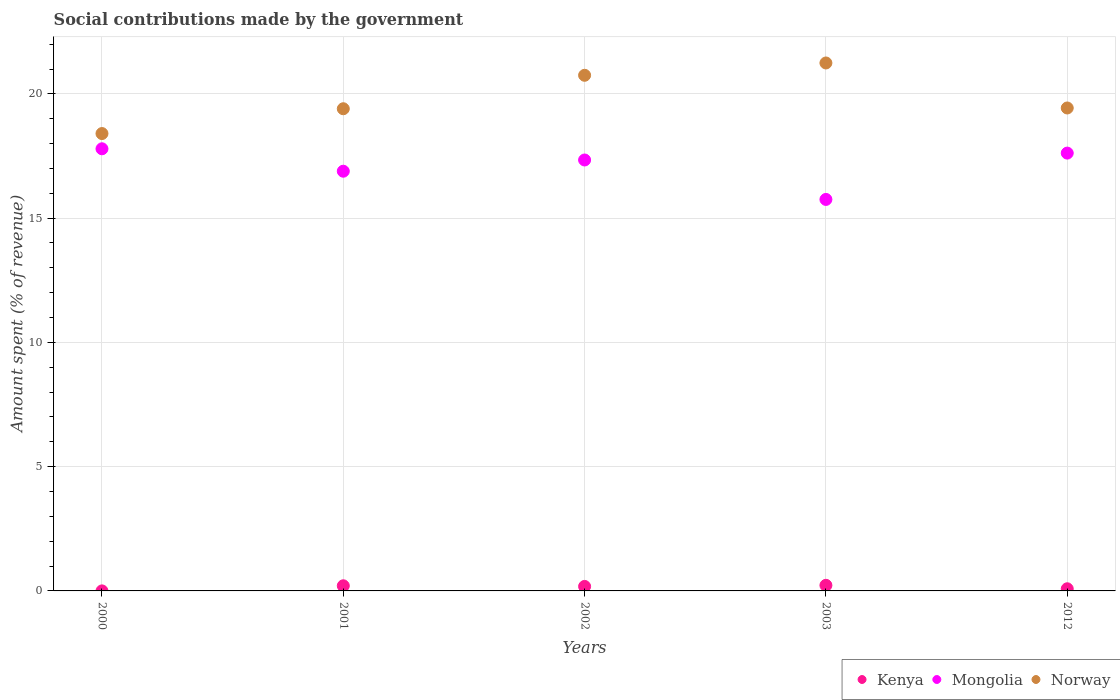How many different coloured dotlines are there?
Your answer should be compact. 3. What is the amount spent (in %) on social contributions in Mongolia in 2001?
Offer a terse response. 16.89. Across all years, what is the maximum amount spent (in %) on social contributions in Mongolia?
Keep it short and to the point. 17.79. Across all years, what is the minimum amount spent (in %) on social contributions in Kenya?
Ensure brevity in your answer.  0. In which year was the amount spent (in %) on social contributions in Norway minimum?
Give a very brief answer. 2000. What is the total amount spent (in %) on social contributions in Mongolia in the graph?
Keep it short and to the point. 85.39. What is the difference between the amount spent (in %) on social contributions in Kenya in 2001 and that in 2002?
Your answer should be very brief. 0.03. What is the difference between the amount spent (in %) on social contributions in Norway in 2003 and the amount spent (in %) on social contributions in Mongolia in 2001?
Provide a short and direct response. 4.36. What is the average amount spent (in %) on social contributions in Mongolia per year?
Your response must be concise. 17.08. In the year 2002, what is the difference between the amount spent (in %) on social contributions in Mongolia and amount spent (in %) on social contributions in Kenya?
Offer a terse response. 17.16. In how many years, is the amount spent (in %) on social contributions in Norway greater than 19 %?
Ensure brevity in your answer.  4. What is the ratio of the amount spent (in %) on social contributions in Kenya in 2002 to that in 2003?
Provide a succinct answer. 0.8. Is the amount spent (in %) on social contributions in Mongolia in 2000 less than that in 2001?
Your answer should be very brief. No. Is the difference between the amount spent (in %) on social contributions in Mongolia in 2002 and 2003 greater than the difference between the amount spent (in %) on social contributions in Kenya in 2002 and 2003?
Offer a very short reply. Yes. What is the difference between the highest and the second highest amount spent (in %) on social contributions in Mongolia?
Make the answer very short. 0.17. What is the difference between the highest and the lowest amount spent (in %) on social contributions in Norway?
Provide a short and direct response. 2.84. Is the sum of the amount spent (in %) on social contributions in Mongolia in 2001 and 2002 greater than the maximum amount spent (in %) on social contributions in Kenya across all years?
Your answer should be compact. Yes. Is it the case that in every year, the sum of the amount spent (in %) on social contributions in Norway and amount spent (in %) on social contributions in Kenya  is greater than the amount spent (in %) on social contributions in Mongolia?
Keep it short and to the point. Yes. Is the amount spent (in %) on social contributions in Kenya strictly greater than the amount spent (in %) on social contributions in Norway over the years?
Give a very brief answer. No. Is the amount spent (in %) on social contributions in Kenya strictly less than the amount spent (in %) on social contributions in Mongolia over the years?
Ensure brevity in your answer.  Yes. How many dotlines are there?
Your response must be concise. 3. How many years are there in the graph?
Keep it short and to the point. 5. What is the difference between two consecutive major ticks on the Y-axis?
Provide a succinct answer. 5. Are the values on the major ticks of Y-axis written in scientific E-notation?
Keep it short and to the point. No. Does the graph contain grids?
Give a very brief answer. Yes. Where does the legend appear in the graph?
Your answer should be very brief. Bottom right. How many legend labels are there?
Ensure brevity in your answer.  3. How are the legend labels stacked?
Your answer should be very brief. Horizontal. What is the title of the graph?
Give a very brief answer. Social contributions made by the government. What is the label or title of the Y-axis?
Offer a very short reply. Amount spent (% of revenue). What is the Amount spent (% of revenue) of Kenya in 2000?
Provide a short and direct response. 0. What is the Amount spent (% of revenue) in Mongolia in 2000?
Offer a very short reply. 17.79. What is the Amount spent (% of revenue) in Norway in 2000?
Give a very brief answer. 18.4. What is the Amount spent (% of revenue) in Kenya in 2001?
Give a very brief answer. 0.21. What is the Amount spent (% of revenue) in Mongolia in 2001?
Provide a short and direct response. 16.89. What is the Amount spent (% of revenue) in Norway in 2001?
Provide a short and direct response. 19.4. What is the Amount spent (% of revenue) in Kenya in 2002?
Provide a succinct answer. 0.18. What is the Amount spent (% of revenue) in Mongolia in 2002?
Your response must be concise. 17.34. What is the Amount spent (% of revenue) of Norway in 2002?
Offer a very short reply. 20.75. What is the Amount spent (% of revenue) of Kenya in 2003?
Your answer should be compact. 0.23. What is the Amount spent (% of revenue) in Mongolia in 2003?
Your response must be concise. 15.75. What is the Amount spent (% of revenue) in Norway in 2003?
Keep it short and to the point. 21.24. What is the Amount spent (% of revenue) of Kenya in 2012?
Your answer should be compact. 0.09. What is the Amount spent (% of revenue) of Mongolia in 2012?
Your answer should be compact. 17.62. What is the Amount spent (% of revenue) of Norway in 2012?
Ensure brevity in your answer.  19.43. Across all years, what is the maximum Amount spent (% of revenue) in Kenya?
Provide a short and direct response. 0.23. Across all years, what is the maximum Amount spent (% of revenue) of Mongolia?
Your answer should be compact. 17.79. Across all years, what is the maximum Amount spent (% of revenue) of Norway?
Your response must be concise. 21.24. Across all years, what is the minimum Amount spent (% of revenue) of Kenya?
Ensure brevity in your answer.  0. Across all years, what is the minimum Amount spent (% of revenue) of Mongolia?
Your answer should be very brief. 15.75. Across all years, what is the minimum Amount spent (% of revenue) in Norway?
Keep it short and to the point. 18.4. What is the total Amount spent (% of revenue) of Mongolia in the graph?
Your answer should be compact. 85.39. What is the total Amount spent (% of revenue) of Norway in the graph?
Offer a terse response. 99.23. What is the difference between the Amount spent (% of revenue) in Kenya in 2000 and that in 2001?
Your answer should be compact. -0.21. What is the difference between the Amount spent (% of revenue) of Mongolia in 2000 and that in 2001?
Offer a very short reply. 0.9. What is the difference between the Amount spent (% of revenue) of Norway in 2000 and that in 2001?
Your answer should be very brief. -1. What is the difference between the Amount spent (% of revenue) in Kenya in 2000 and that in 2002?
Make the answer very short. -0.18. What is the difference between the Amount spent (% of revenue) of Mongolia in 2000 and that in 2002?
Give a very brief answer. 0.45. What is the difference between the Amount spent (% of revenue) in Norway in 2000 and that in 2002?
Make the answer very short. -2.34. What is the difference between the Amount spent (% of revenue) in Kenya in 2000 and that in 2003?
Keep it short and to the point. -0.22. What is the difference between the Amount spent (% of revenue) in Mongolia in 2000 and that in 2003?
Give a very brief answer. 2.04. What is the difference between the Amount spent (% of revenue) of Norway in 2000 and that in 2003?
Your answer should be very brief. -2.84. What is the difference between the Amount spent (% of revenue) of Kenya in 2000 and that in 2012?
Your answer should be compact. -0.09. What is the difference between the Amount spent (% of revenue) in Mongolia in 2000 and that in 2012?
Give a very brief answer. 0.17. What is the difference between the Amount spent (% of revenue) in Norway in 2000 and that in 2012?
Your answer should be compact. -1.03. What is the difference between the Amount spent (% of revenue) of Kenya in 2001 and that in 2002?
Offer a very short reply. 0.03. What is the difference between the Amount spent (% of revenue) in Mongolia in 2001 and that in 2002?
Offer a terse response. -0.45. What is the difference between the Amount spent (% of revenue) of Norway in 2001 and that in 2002?
Offer a terse response. -1.35. What is the difference between the Amount spent (% of revenue) of Kenya in 2001 and that in 2003?
Provide a short and direct response. -0.02. What is the difference between the Amount spent (% of revenue) in Mongolia in 2001 and that in 2003?
Make the answer very short. 1.14. What is the difference between the Amount spent (% of revenue) of Norway in 2001 and that in 2003?
Keep it short and to the point. -1.84. What is the difference between the Amount spent (% of revenue) of Kenya in 2001 and that in 2012?
Ensure brevity in your answer.  0.12. What is the difference between the Amount spent (% of revenue) of Mongolia in 2001 and that in 2012?
Your answer should be compact. -0.73. What is the difference between the Amount spent (% of revenue) in Norway in 2001 and that in 2012?
Provide a short and direct response. -0.03. What is the difference between the Amount spent (% of revenue) in Kenya in 2002 and that in 2003?
Offer a very short reply. -0.04. What is the difference between the Amount spent (% of revenue) in Mongolia in 2002 and that in 2003?
Ensure brevity in your answer.  1.59. What is the difference between the Amount spent (% of revenue) of Norway in 2002 and that in 2003?
Offer a very short reply. -0.5. What is the difference between the Amount spent (% of revenue) in Kenya in 2002 and that in 2012?
Your answer should be compact. 0.09. What is the difference between the Amount spent (% of revenue) in Mongolia in 2002 and that in 2012?
Keep it short and to the point. -0.28. What is the difference between the Amount spent (% of revenue) in Norway in 2002 and that in 2012?
Your answer should be very brief. 1.32. What is the difference between the Amount spent (% of revenue) of Kenya in 2003 and that in 2012?
Offer a terse response. 0.14. What is the difference between the Amount spent (% of revenue) in Mongolia in 2003 and that in 2012?
Make the answer very short. -1.86. What is the difference between the Amount spent (% of revenue) of Norway in 2003 and that in 2012?
Provide a succinct answer. 1.81. What is the difference between the Amount spent (% of revenue) of Kenya in 2000 and the Amount spent (% of revenue) of Mongolia in 2001?
Offer a terse response. -16.89. What is the difference between the Amount spent (% of revenue) in Kenya in 2000 and the Amount spent (% of revenue) in Norway in 2001?
Ensure brevity in your answer.  -19.4. What is the difference between the Amount spent (% of revenue) of Mongolia in 2000 and the Amount spent (% of revenue) of Norway in 2001?
Give a very brief answer. -1.61. What is the difference between the Amount spent (% of revenue) in Kenya in 2000 and the Amount spent (% of revenue) in Mongolia in 2002?
Your answer should be very brief. -17.34. What is the difference between the Amount spent (% of revenue) in Kenya in 2000 and the Amount spent (% of revenue) in Norway in 2002?
Your response must be concise. -20.75. What is the difference between the Amount spent (% of revenue) of Mongolia in 2000 and the Amount spent (% of revenue) of Norway in 2002?
Offer a very short reply. -2.96. What is the difference between the Amount spent (% of revenue) of Kenya in 2000 and the Amount spent (% of revenue) of Mongolia in 2003?
Your answer should be very brief. -15.75. What is the difference between the Amount spent (% of revenue) in Kenya in 2000 and the Amount spent (% of revenue) in Norway in 2003?
Your response must be concise. -21.24. What is the difference between the Amount spent (% of revenue) of Mongolia in 2000 and the Amount spent (% of revenue) of Norway in 2003?
Your answer should be very brief. -3.45. What is the difference between the Amount spent (% of revenue) of Kenya in 2000 and the Amount spent (% of revenue) of Mongolia in 2012?
Give a very brief answer. -17.62. What is the difference between the Amount spent (% of revenue) of Kenya in 2000 and the Amount spent (% of revenue) of Norway in 2012?
Your answer should be compact. -19.43. What is the difference between the Amount spent (% of revenue) in Mongolia in 2000 and the Amount spent (% of revenue) in Norway in 2012?
Keep it short and to the point. -1.64. What is the difference between the Amount spent (% of revenue) in Kenya in 2001 and the Amount spent (% of revenue) in Mongolia in 2002?
Provide a short and direct response. -17.13. What is the difference between the Amount spent (% of revenue) of Kenya in 2001 and the Amount spent (% of revenue) of Norway in 2002?
Your answer should be compact. -20.54. What is the difference between the Amount spent (% of revenue) in Mongolia in 2001 and the Amount spent (% of revenue) in Norway in 2002?
Keep it short and to the point. -3.86. What is the difference between the Amount spent (% of revenue) of Kenya in 2001 and the Amount spent (% of revenue) of Mongolia in 2003?
Keep it short and to the point. -15.55. What is the difference between the Amount spent (% of revenue) in Kenya in 2001 and the Amount spent (% of revenue) in Norway in 2003?
Ensure brevity in your answer.  -21.04. What is the difference between the Amount spent (% of revenue) of Mongolia in 2001 and the Amount spent (% of revenue) of Norway in 2003?
Your response must be concise. -4.36. What is the difference between the Amount spent (% of revenue) of Kenya in 2001 and the Amount spent (% of revenue) of Mongolia in 2012?
Provide a succinct answer. -17.41. What is the difference between the Amount spent (% of revenue) in Kenya in 2001 and the Amount spent (% of revenue) in Norway in 2012?
Offer a terse response. -19.23. What is the difference between the Amount spent (% of revenue) of Mongolia in 2001 and the Amount spent (% of revenue) of Norway in 2012?
Offer a terse response. -2.54. What is the difference between the Amount spent (% of revenue) in Kenya in 2002 and the Amount spent (% of revenue) in Mongolia in 2003?
Give a very brief answer. -15.57. What is the difference between the Amount spent (% of revenue) of Kenya in 2002 and the Amount spent (% of revenue) of Norway in 2003?
Keep it short and to the point. -21.06. What is the difference between the Amount spent (% of revenue) in Mongolia in 2002 and the Amount spent (% of revenue) in Norway in 2003?
Provide a succinct answer. -3.9. What is the difference between the Amount spent (% of revenue) of Kenya in 2002 and the Amount spent (% of revenue) of Mongolia in 2012?
Ensure brevity in your answer.  -17.44. What is the difference between the Amount spent (% of revenue) of Kenya in 2002 and the Amount spent (% of revenue) of Norway in 2012?
Offer a very short reply. -19.25. What is the difference between the Amount spent (% of revenue) in Mongolia in 2002 and the Amount spent (% of revenue) in Norway in 2012?
Keep it short and to the point. -2.09. What is the difference between the Amount spent (% of revenue) of Kenya in 2003 and the Amount spent (% of revenue) of Mongolia in 2012?
Offer a very short reply. -17.39. What is the difference between the Amount spent (% of revenue) of Kenya in 2003 and the Amount spent (% of revenue) of Norway in 2012?
Ensure brevity in your answer.  -19.21. What is the difference between the Amount spent (% of revenue) in Mongolia in 2003 and the Amount spent (% of revenue) in Norway in 2012?
Give a very brief answer. -3.68. What is the average Amount spent (% of revenue) in Kenya per year?
Give a very brief answer. 0.14. What is the average Amount spent (% of revenue) of Mongolia per year?
Your answer should be compact. 17.08. What is the average Amount spent (% of revenue) in Norway per year?
Ensure brevity in your answer.  19.85. In the year 2000, what is the difference between the Amount spent (% of revenue) of Kenya and Amount spent (% of revenue) of Mongolia?
Your response must be concise. -17.79. In the year 2000, what is the difference between the Amount spent (% of revenue) of Kenya and Amount spent (% of revenue) of Norway?
Ensure brevity in your answer.  -18.4. In the year 2000, what is the difference between the Amount spent (% of revenue) of Mongolia and Amount spent (% of revenue) of Norway?
Your response must be concise. -0.61. In the year 2001, what is the difference between the Amount spent (% of revenue) of Kenya and Amount spent (% of revenue) of Mongolia?
Provide a succinct answer. -16.68. In the year 2001, what is the difference between the Amount spent (% of revenue) of Kenya and Amount spent (% of revenue) of Norway?
Make the answer very short. -19.2. In the year 2001, what is the difference between the Amount spent (% of revenue) in Mongolia and Amount spent (% of revenue) in Norway?
Your answer should be very brief. -2.51. In the year 2002, what is the difference between the Amount spent (% of revenue) in Kenya and Amount spent (% of revenue) in Mongolia?
Your answer should be very brief. -17.16. In the year 2002, what is the difference between the Amount spent (% of revenue) of Kenya and Amount spent (% of revenue) of Norway?
Your answer should be compact. -20.57. In the year 2002, what is the difference between the Amount spent (% of revenue) of Mongolia and Amount spent (% of revenue) of Norway?
Your answer should be very brief. -3.41. In the year 2003, what is the difference between the Amount spent (% of revenue) of Kenya and Amount spent (% of revenue) of Mongolia?
Your answer should be very brief. -15.53. In the year 2003, what is the difference between the Amount spent (% of revenue) in Kenya and Amount spent (% of revenue) in Norway?
Your answer should be compact. -21.02. In the year 2003, what is the difference between the Amount spent (% of revenue) in Mongolia and Amount spent (% of revenue) in Norway?
Provide a short and direct response. -5.49. In the year 2012, what is the difference between the Amount spent (% of revenue) of Kenya and Amount spent (% of revenue) of Mongolia?
Offer a terse response. -17.53. In the year 2012, what is the difference between the Amount spent (% of revenue) in Kenya and Amount spent (% of revenue) in Norway?
Keep it short and to the point. -19.35. In the year 2012, what is the difference between the Amount spent (% of revenue) in Mongolia and Amount spent (% of revenue) in Norway?
Ensure brevity in your answer.  -1.82. What is the ratio of the Amount spent (% of revenue) of Kenya in 2000 to that in 2001?
Provide a succinct answer. 0.01. What is the ratio of the Amount spent (% of revenue) of Mongolia in 2000 to that in 2001?
Give a very brief answer. 1.05. What is the ratio of the Amount spent (% of revenue) in Norway in 2000 to that in 2001?
Your response must be concise. 0.95. What is the ratio of the Amount spent (% of revenue) in Kenya in 2000 to that in 2002?
Give a very brief answer. 0.01. What is the ratio of the Amount spent (% of revenue) in Mongolia in 2000 to that in 2002?
Provide a short and direct response. 1.03. What is the ratio of the Amount spent (% of revenue) in Norway in 2000 to that in 2002?
Ensure brevity in your answer.  0.89. What is the ratio of the Amount spent (% of revenue) of Kenya in 2000 to that in 2003?
Make the answer very short. 0. What is the ratio of the Amount spent (% of revenue) in Mongolia in 2000 to that in 2003?
Offer a very short reply. 1.13. What is the ratio of the Amount spent (% of revenue) of Norway in 2000 to that in 2003?
Offer a terse response. 0.87. What is the ratio of the Amount spent (% of revenue) in Kenya in 2000 to that in 2012?
Offer a very short reply. 0.01. What is the ratio of the Amount spent (% of revenue) in Mongolia in 2000 to that in 2012?
Offer a very short reply. 1.01. What is the ratio of the Amount spent (% of revenue) of Norway in 2000 to that in 2012?
Your answer should be compact. 0.95. What is the ratio of the Amount spent (% of revenue) in Kenya in 2001 to that in 2002?
Offer a very short reply. 1.14. What is the ratio of the Amount spent (% of revenue) in Mongolia in 2001 to that in 2002?
Provide a short and direct response. 0.97. What is the ratio of the Amount spent (% of revenue) in Norway in 2001 to that in 2002?
Give a very brief answer. 0.94. What is the ratio of the Amount spent (% of revenue) of Kenya in 2001 to that in 2003?
Your answer should be very brief. 0.92. What is the ratio of the Amount spent (% of revenue) in Mongolia in 2001 to that in 2003?
Give a very brief answer. 1.07. What is the ratio of the Amount spent (% of revenue) in Norway in 2001 to that in 2003?
Offer a very short reply. 0.91. What is the ratio of the Amount spent (% of revenue) of Kenya in 2001 to that in 2012?
Make the answer very short. 2.39. What is the ratio of the Amount spent (% of revenue) in Mongolia in 2001 to that in 2012?
Provide a short and direct response. 0.96. What is the ratio of the Amount spent (% of revenue) in Kenya in 2002 to that in 2003?
Keep it short and to the point. 0.8. What is the ratio of the Amount spent (% of revenue) of Mongolia in 2002 to that in 2003?
Offer a terse response. 1.1. What is the ratio of the Amount spent (% of revenue) in Norway in 2002 to that in 2003?
Provide a short and direct response. 0.98. What is the ratio of the Amount spent (% of revenue) of Kenya in 2002 to that in 2012?
Ensure brevity in your answer.  2.09. What is the ratio of the Amount spent (% of revenue) in Mongolia in 2002 to that in 2012?
Offer a very short reply. 0.98. What is the ratio of the Amount spent (% of revenue) in Norway in 2002 to that in 2012?
Give a very brief answer. 1.07. What is the ratio of the Amount spent (% of revenue) in Kenya in 2003 to that in 2012?
Your answer should be very brief. 2.61. What is the ratio of the Amount spent (% of revenue) in Mongolia in 2003 to that in 2012?
Keep it short and to the point. 0.89. What is the ratio of the Amount spent (% of revenue) in Norway in 2003 to that in 2012?
Offer a terse response. 1.09. What is the difference between the highest and the second highest Amount spent (% of revenue) of Kenya?
Offer a terse response. 0.02. What is the difference between the highest and the second highest Amount spent (% of revenue) of Mongolia?
Provide a succinct answer. 0.17. What is the difference between the highest and the second highest Amount spent (% of revenue) in Norway?
Make the answer very short. 0.5. What is the difference between the highest and the lowest Amount spent (% of revenue) of Kenya?
Your answer should be compact. 0.22. What is the difference between the highest and the lowest Amount spent (% of revenue) of Mongolia?
Your answer should be very brief. 2.04. What is the difference between the highest and the lowest Amount spent (% of revenue) of Norway?
Provide a succinct answer. 2.84. 